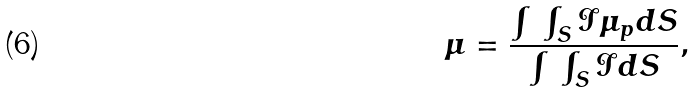<formula> <loc_0><loc_0><loc_500><loc_500>\mu = \frac { \int \, \int _ { S } \mathcal { I } \mu _ { p } d S } { \int \, \int _ { S } \mathcal { I } d S } ,</formula> 